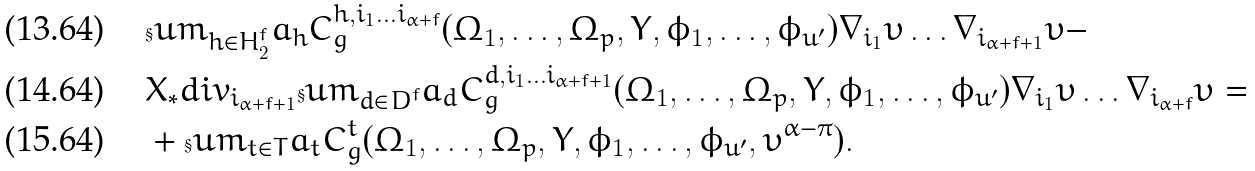Convert formula to latex. <formula><loc_0><loc_0><loc_500><loc_500>& \S u m _ { h \in H ^ { f } _ { 2 } } a _ { h } C ^ { h , i _ { 1 } \dots i _ { \alpha + f } } _ { g } ( \Omega _ { 1 } , \dots , \Omega _ { p } , Y , \phi _ { 1 } , \dots , \phi _ { u ^ { \prime } } ) \nabla _ { i _ { 1 } } \upsilon \dots \nabla _ { i _ { \alpha + f + 1 } } \upsilon - \\ & X _ { * } d i v _ { i _ { \alpha + f + 1 } } \S u m _ { d \in D ^ { f } } a _ { d } C ^ { d , i _ { 1 } \dots i _ { \alpha + f + 1 } } _ { g } ( \Omega _ { 1 } , \dots , \Omega _ { p } , Y , \phi _ { 1 } , \dots , \phi _ { u ^ { \prime } } ) \nabla _ { i _ { 1 } } \upsilon \dots \nabla _ { i _ { \alpha + f } } \upsilon = \\ & + \S u m _ { t \in T } a _ { t } C ^ { t } _ { g } ( \Omega _ { 1 } , \dots , \Omega _ { p } , Y , \phi _ { 1 } , \dots , \phi _ { u ^ { \prime } } , \upsilon ^ { \alpha - \pi } ) .</formula> 